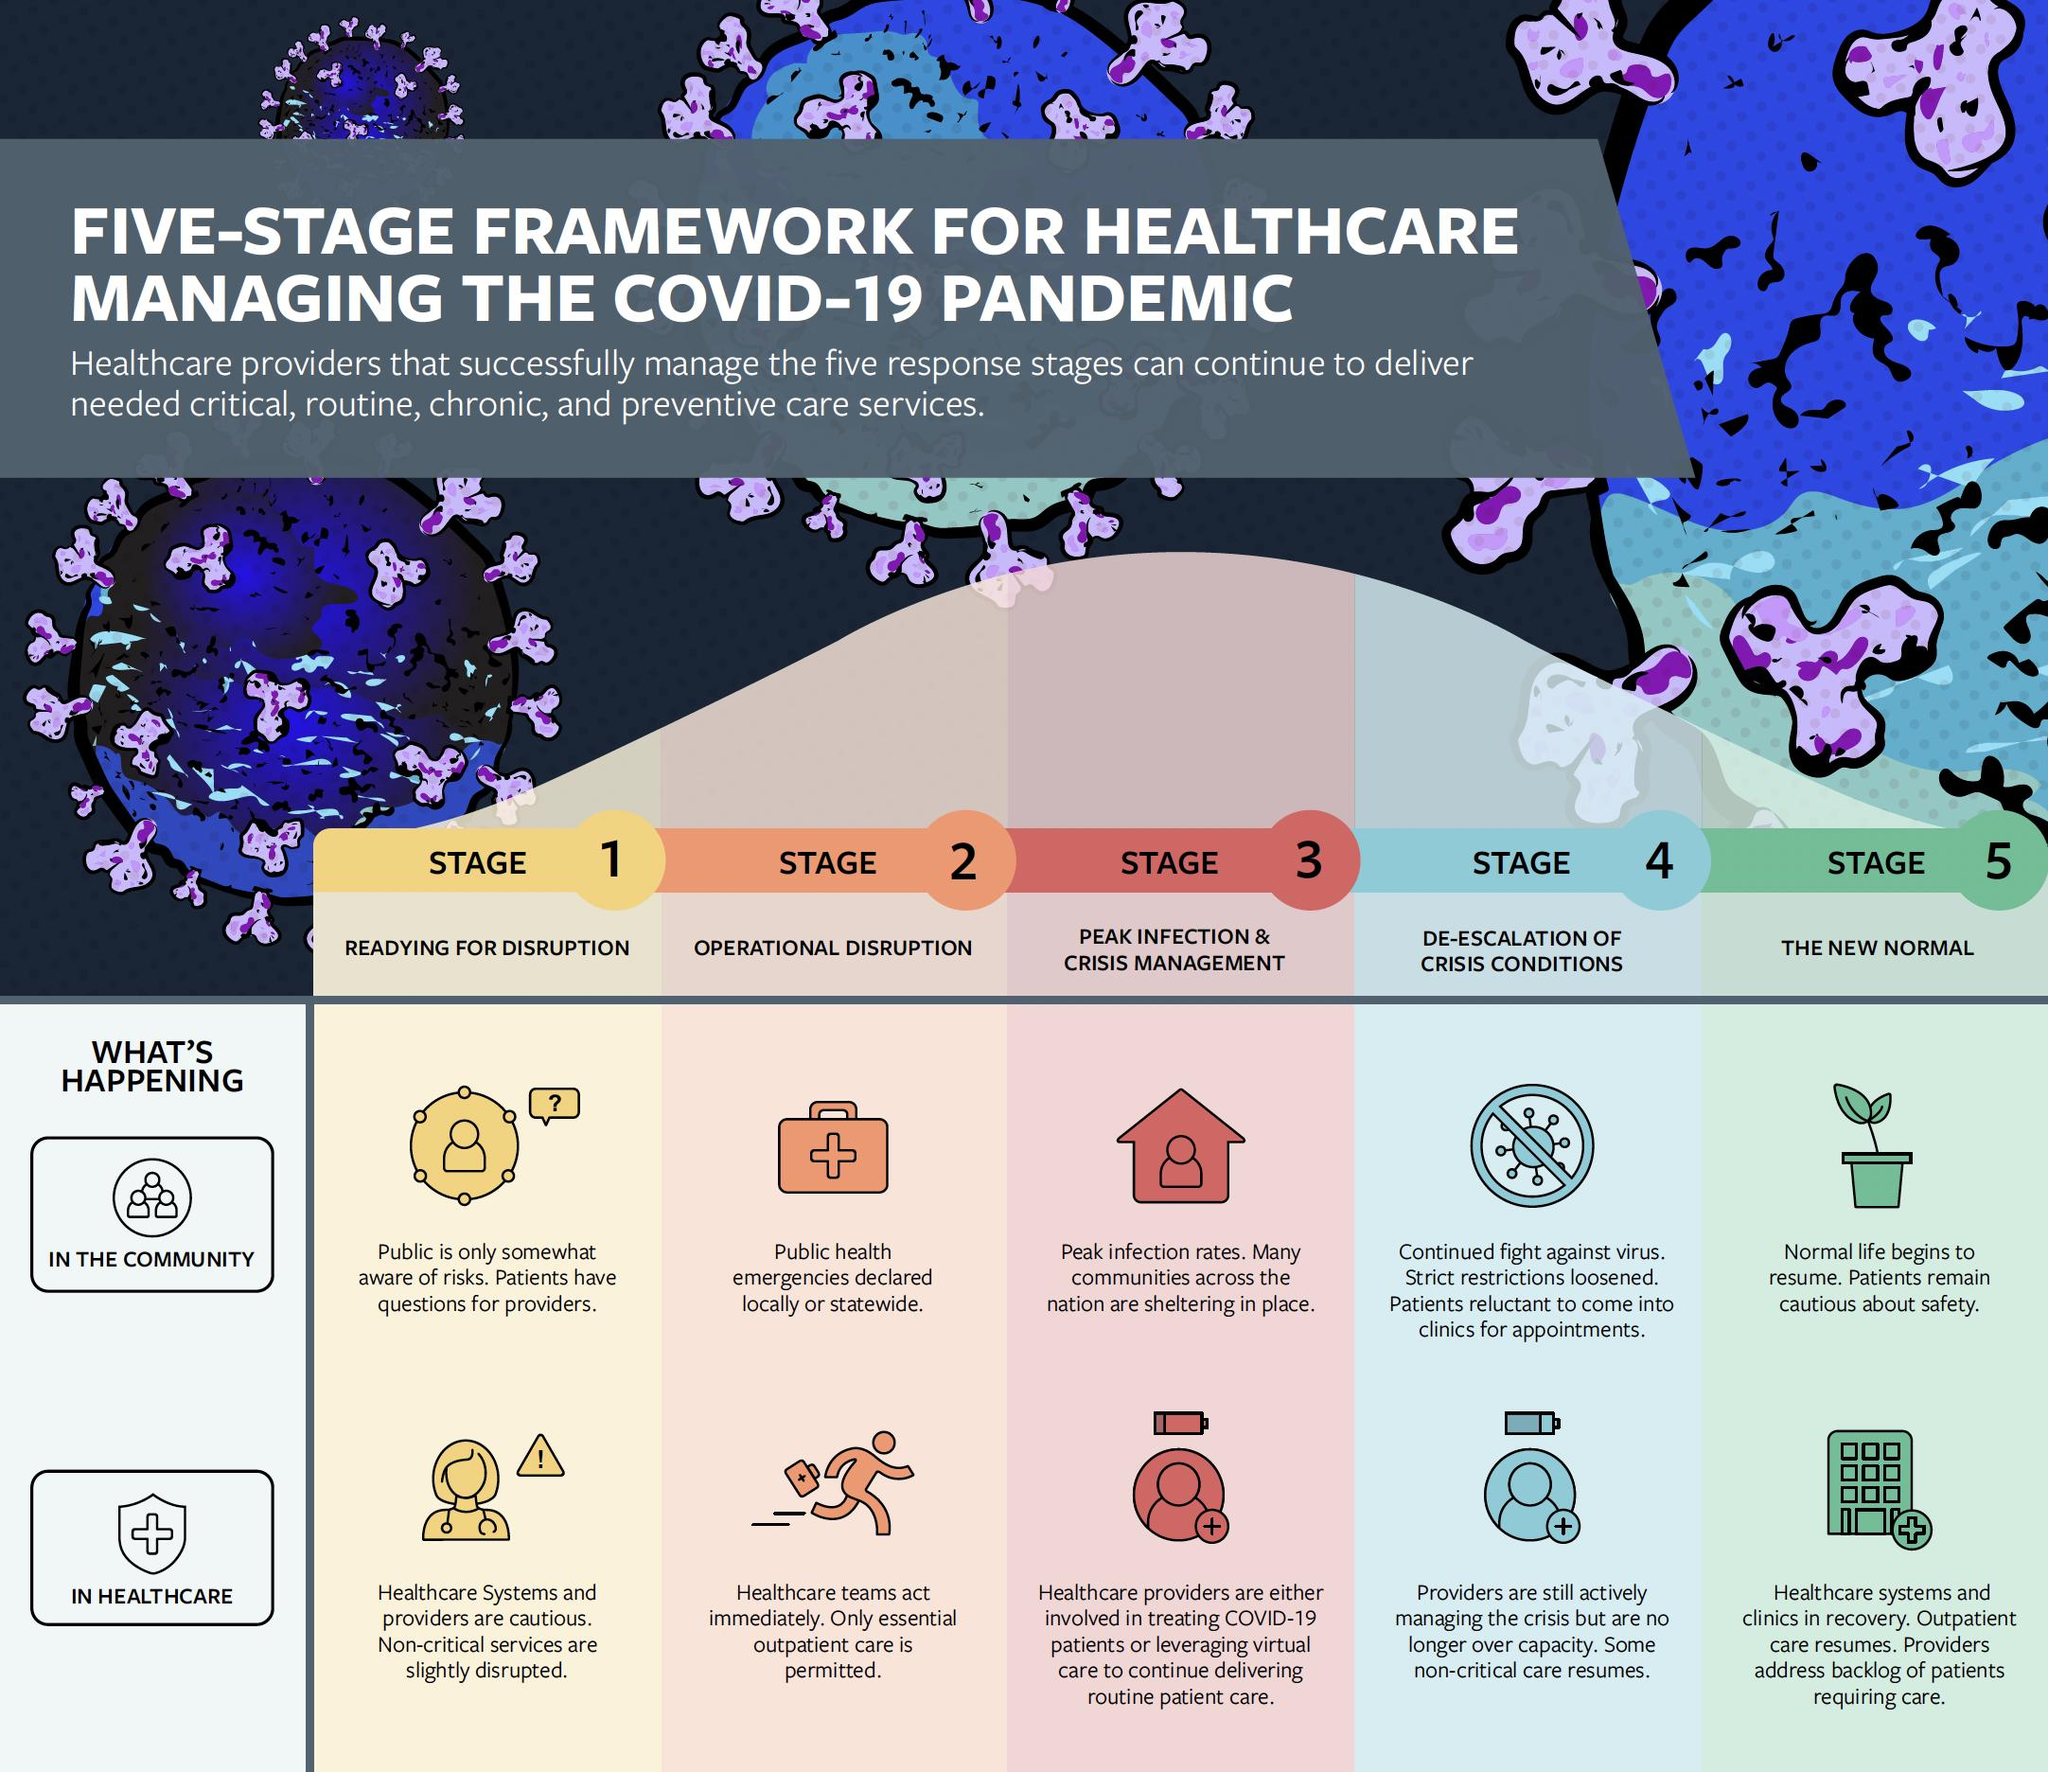Mention a couple of crucial points in this snapshot. The community and health care segments are the two response stages that are shown in this context. The first two response stages in the framework of healthcare management are readying for disruption and operational disruption. In the first stage, the public is not fully aware of the risks associated with climate change, and the scientific consensus on the issue is not yet universally accepted. Public health emergencies have been declared locally or statewide, specifically in Stage 2. In the healthcare sector, non-critical care activities have resumed in Stage 4. 